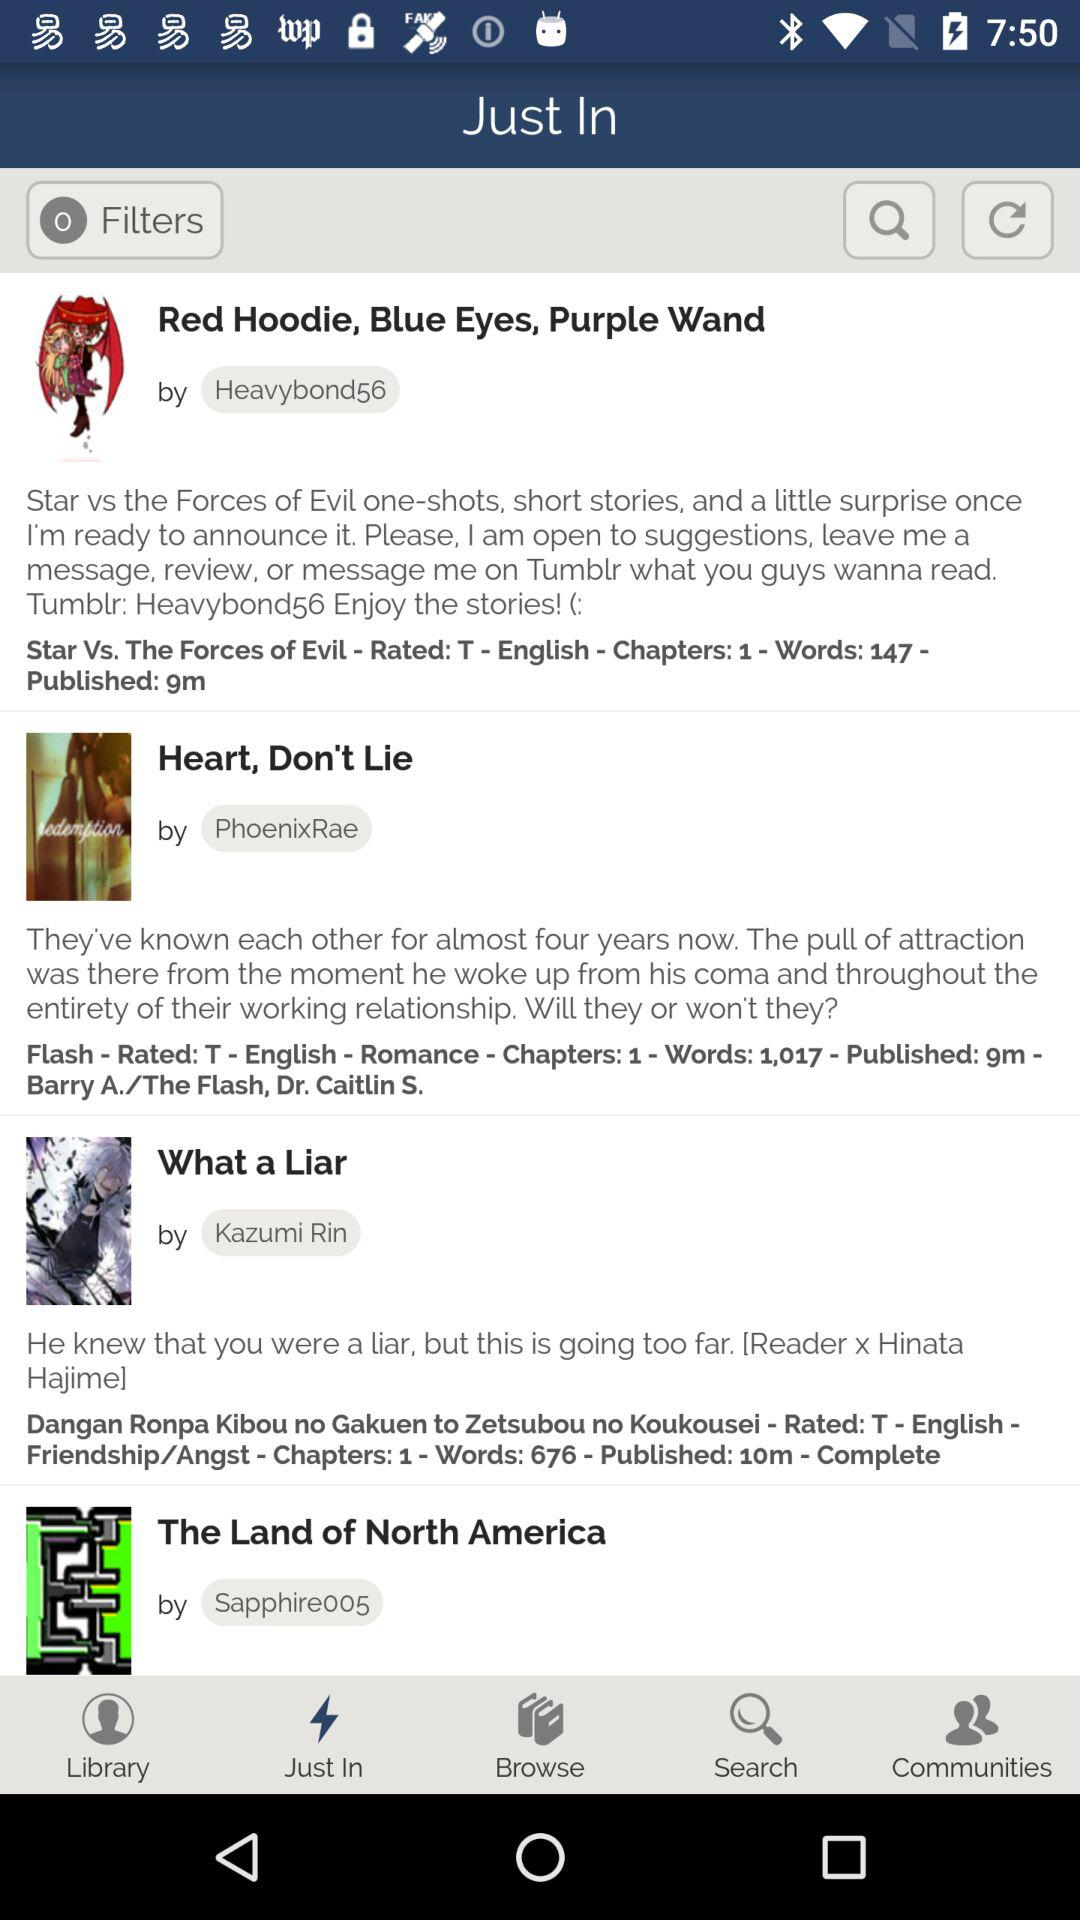What is the author's name for "What a Liar"? The author's name is Kazumi Rin. 